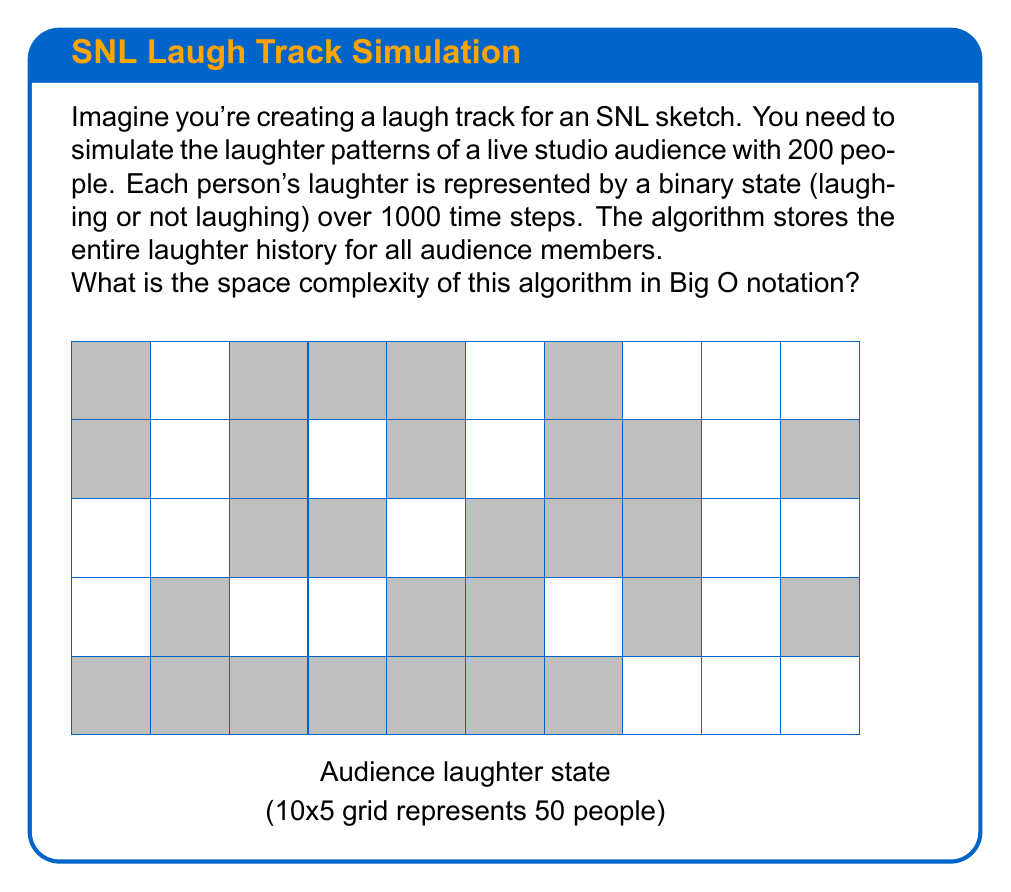What is the answer to this math problem? To determine the space complexity, let's break down the problem:

1. Number of audience members: $n = 200$
2. Number of time steps: $t = 1000$
3. Each person's laughter state at each time step: 1 bit (0 or 1)

The total space required can be calculated as follows:

1. Space for one person's laughter history:
   $$ \text{Space per person} = t \text{ bits} = 1000 \text{ bits} $$

2. Space for all audience members:
   $$ \text{Total space} = n \times t \text{ bits} = 200 \times 1000 \text{ bits} = 200,000 \text{ bits} $$

3. This can be expressed as:
   $$ \text{Space} = O(n \times t) $$

4. Since both $n$ and $t$ are constants in this specific problem (200 and 1000 respectively), we could technically simplify it to $O(1)$. However, for a general analysis where $n$ and $t$ can vary, we keep it as $O(n \times t)$.

5. In Big O notation, we typically express complexity in terms of the input size. Here, the input size is determined by the number of audience members $(n)$, as the time steps $(t)$ could be considered a property of the simulation rather than the input.

Therefore, the space complexity is $O(n)$, where $n$ is the number of audience members.
Answer: $O(n)$ 